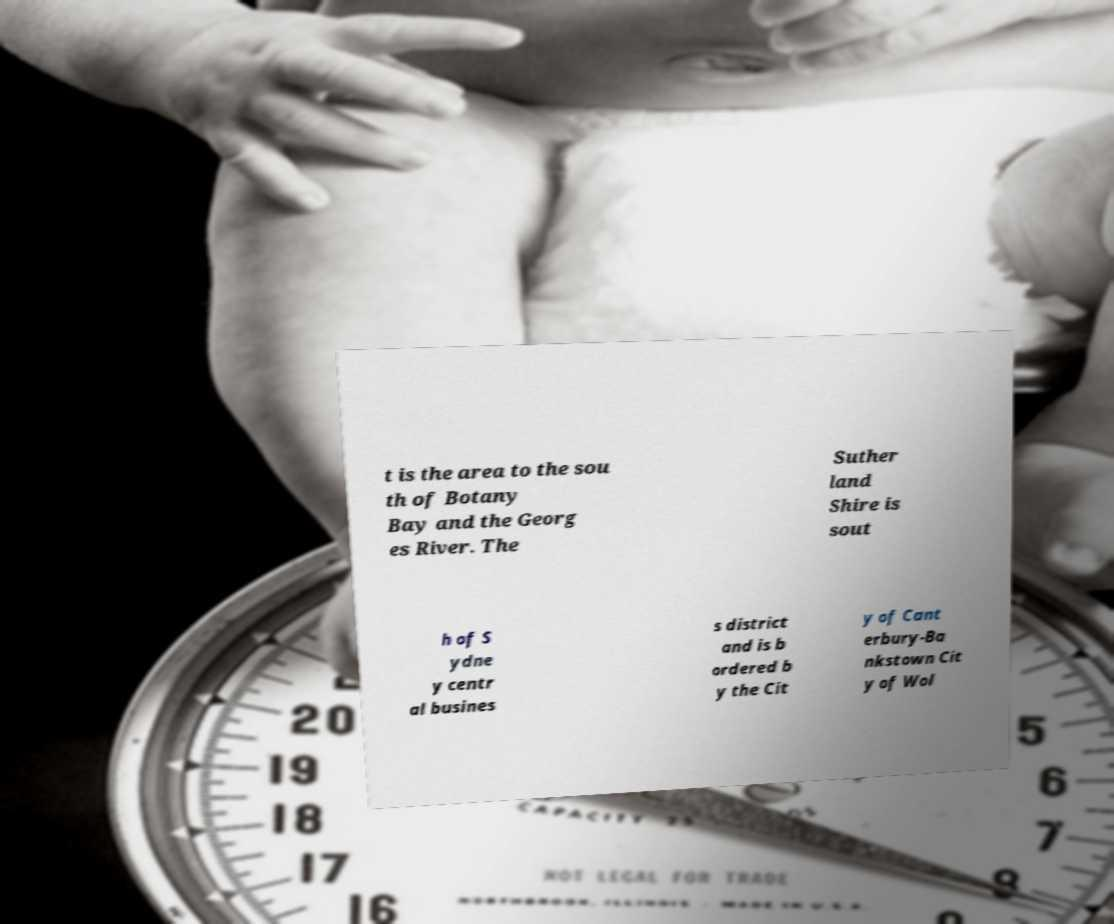Could you assist in decoding the text presented in this image and type it out clearly? t is the area to the sou th of Botany Bay and the Georg es River. The Suther land Shire is sout h of S ydne y centr al busines s district and is b ordered b y the Cit y of Cant erbury-Ba nkstown Cit y of Wol 